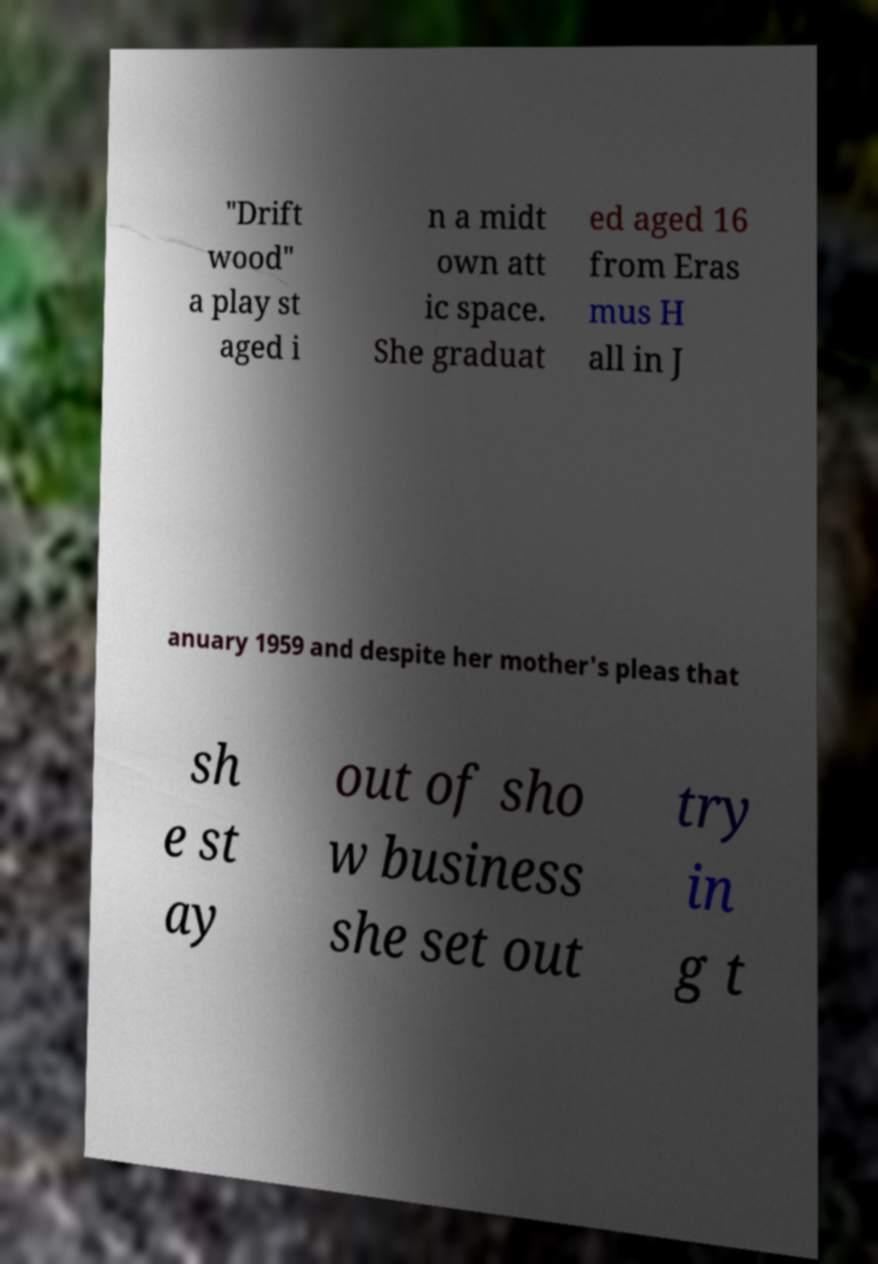Can you read and provide the text displayed in the image?This photo seems to have some interesting text. Can you extract and type it out for me? "Drift wood" a play st aged i n a midt own att ic space. She graduat ed aged 16 from Eras mus H all in J anuary 1959 and despite her mother's pleas that sh e st ay out of sho w business she set out try in g t 